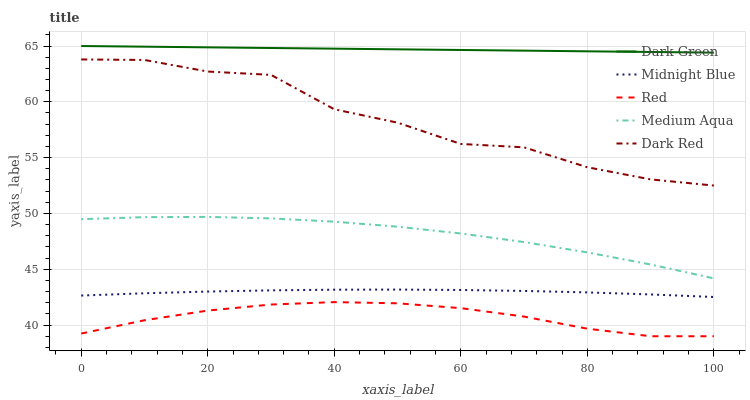Does Red have the minimum area under the curve?
Answer yes or no. Yes. Does Dark Green have the maximum area under the curve?
Answer yes or no. Yes. Does Medium Aqua have the minimum area under the curve?
Answer yes or no. No. Does Medium Aqua have the maximum area under the curve?
Answer yes or no. No. Is Dark Green the smoothest?
Answer yes or no. Yes. Is Dark Red the roughest?
Answer yes or no. Yes. Is Medium Aqua the smoothest?
Answer yes or no. No. Is Medium Aqua the roughest?
Answer yes or no. No. Does Red have the lowest value?
Answer yes or no. Yes. Does Medium Aqua have the lowest value?
Answer yes or no. No. Does Dark Green have the highest value?
Answer yes or no. Yes. Does Medium Aqua have the highest value?
Answer yes or no. No. Is Medium Aqua less than Dark Red?
Answer yes or no. Yes. Is Dark Green greater than Red?
Answer yes or no. Yes. Does Medium Aqua intersect Dark Red?
Answer yes or no. No. 